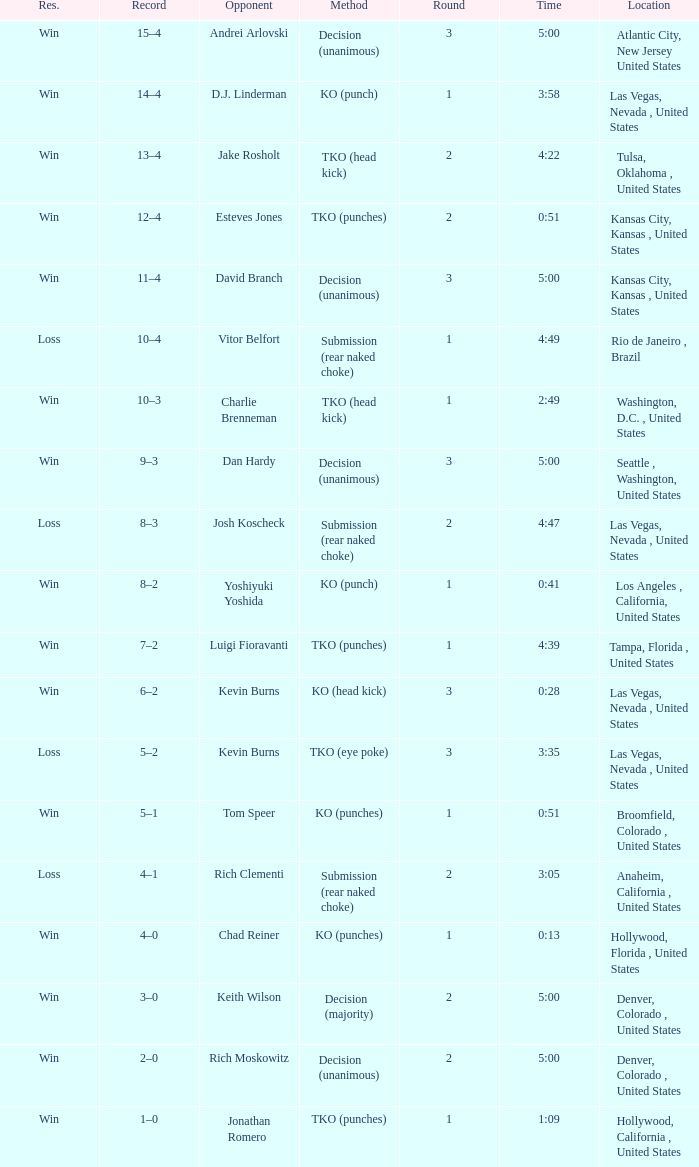Which record has a time of 0:13? 4–0. 